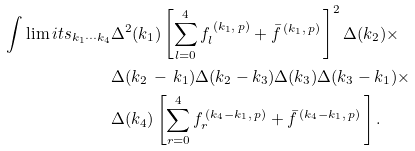Convert formula to latex. <formula><loc_0><loc_0><loc_500><loc_500>\int \lim i t s _ { k _ { 1 } \cdots k _ { 4 } } & \Delta ^ { 2 } ( k _ { 1 } ) \left [ \sum _ { l = 0 } ^ { 4 } f _ { l } ^ { \, ( k _ { 1 } , \, p ) } + { \bar { f } } ^ { \, ( k _ { 1 } , \, p ) } \, \right ] ^ { 2 } \Delta ( k _ { 2 } ) \times \\ & \Delta ( k _ { 2 } \, - \, k _ { 1 } ) \Delta ( k _ { 2 } - k _ { 3 } ) \Delta ( k _ { 3 } ) \Delta ( k _ { 3 } - k _ { 1 } ) \times \\ & \Delta ( k _ { 4 } ) \left [ \sum _ { r = 0 } ^ { 4 } f _ { r } ^ { \, ( k _ { 4 } - k _ { 1 } , \, p ) } + { \bar { f } } ^ { \, ( k _ { 4 } - k _ { 1 } , \, p ) } \, \right ] .</formula> 